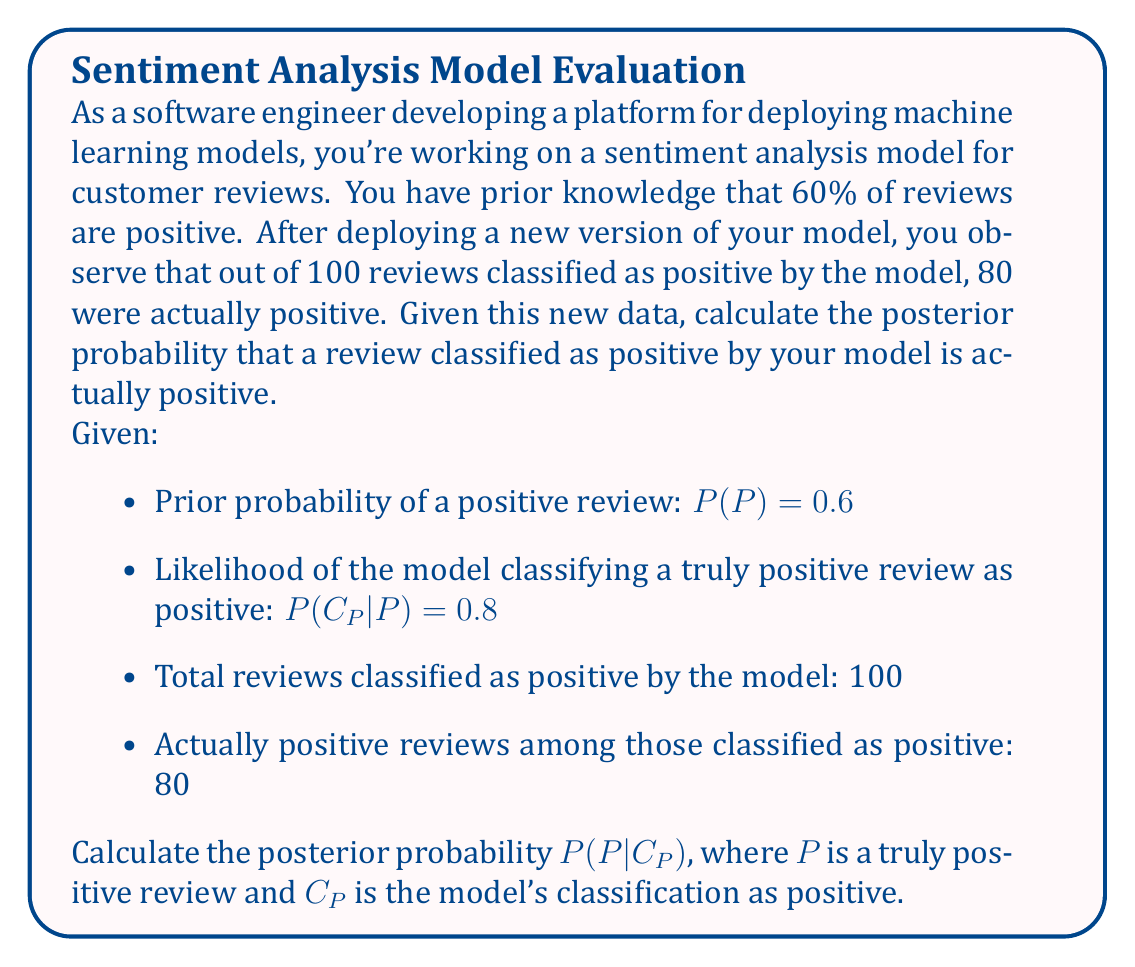Give your solution to this math problem. To solve this problem, we'll use Bayes' theorem:

$$P(P|C_P) = \frac{P(C_P|P) \cdot P(P)}{P(C_P)}$$

We're given:
$P(P) = 0.6$ (prior probability)
$P(C_P|P) = 0.8$ (likelihood)

We need to calculate $P(C_P)$ using the law of total probability:

$$P(C_P) = P(C_P|P) \cdot P(P) + P(C_P|\neg P) \cdot P(\neg P)$$

1. Calculate $P(\neg P)$:
   $P(\neg P) = 1 - P(P) = 1 - 0.6 = 0.4$

2. Calculate $P(C_P|\neg P)$:
   Out of 100 reviews classified as positive, 80 were actually positive.
   So, 20 were falsely classified as positive out of 40 negative reviews.
   $P(C_P|\neg P) = 20 / 40 = 0.5$

3. Calculate $P(C_P)$:
   $P(C_P) = 0.8 \cdot 0.6 + 0.5 \cdot 0.4 = 0.48 + 0.2 = 0.68$

4. Apply Bayes' theorem:
   $$P(P|C_P) = \frac{0.8 \cdot 0.6}{0.68} = \frac{0.48}{0.68} \approx 0.7059$$

Therefore, the posterior probability that a review classified as positive by the model is actually positive is approximately 0.7059 or 70.59%.
Answer: $P(P|C_P) \approx 0.7059$ 